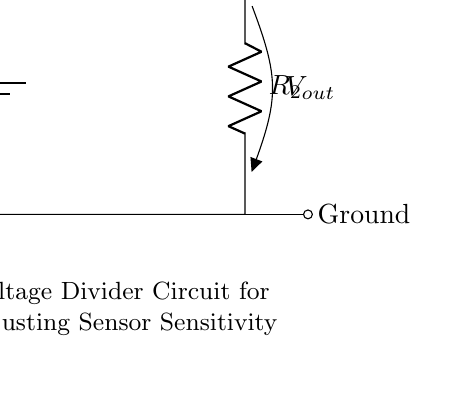What is the input voltage for this circuit? The input voltage is denoted as V_in, which is the voltage provided by the battery in the circuit.
Answer: V_in What components are present in this voltage divider circuit? The circuit contains two resistors, R1 and R2, and a voltage source (battery).
Answer: R1, R2, battery What is the current flowing through R1? The current is represented as I, which flows through both resistors in series in the voltage divider configuration.
Answer: I What is the output voltage taken across? The output voltage V_out is taken across R2, as indicated by the arrow pointing from R2 in the diagram.
Answer: R2 If R1 is twice the value of R2, what can be said about the output voltage V_out? If R1 is twice R2, the output voltage V_out is one-third of the input voltage V_in due to the voltage divider rule, where V_out = R2 / (R1 + R2) * V_in.
Answer: V_out = one-third of V_in How does changing R2 affect the sensitivity of the sensor? Changing R2 will affect the output voltage V_out that the sensor receives, thereby adjusting sensor sensitivity; a larger R2 increases V_out, resulting in a more sensitive sensor.
Answer: Increases sensitivity What is the relationship between V_out and V_in in this circuit? The relationship is defined by the voltage divider formula, V_out = R2 / (R1 + R2) * V_in, indicating that V_out is a fraction of V_in based on the resistor values.
Answer: V_out is a fraction of V_in 